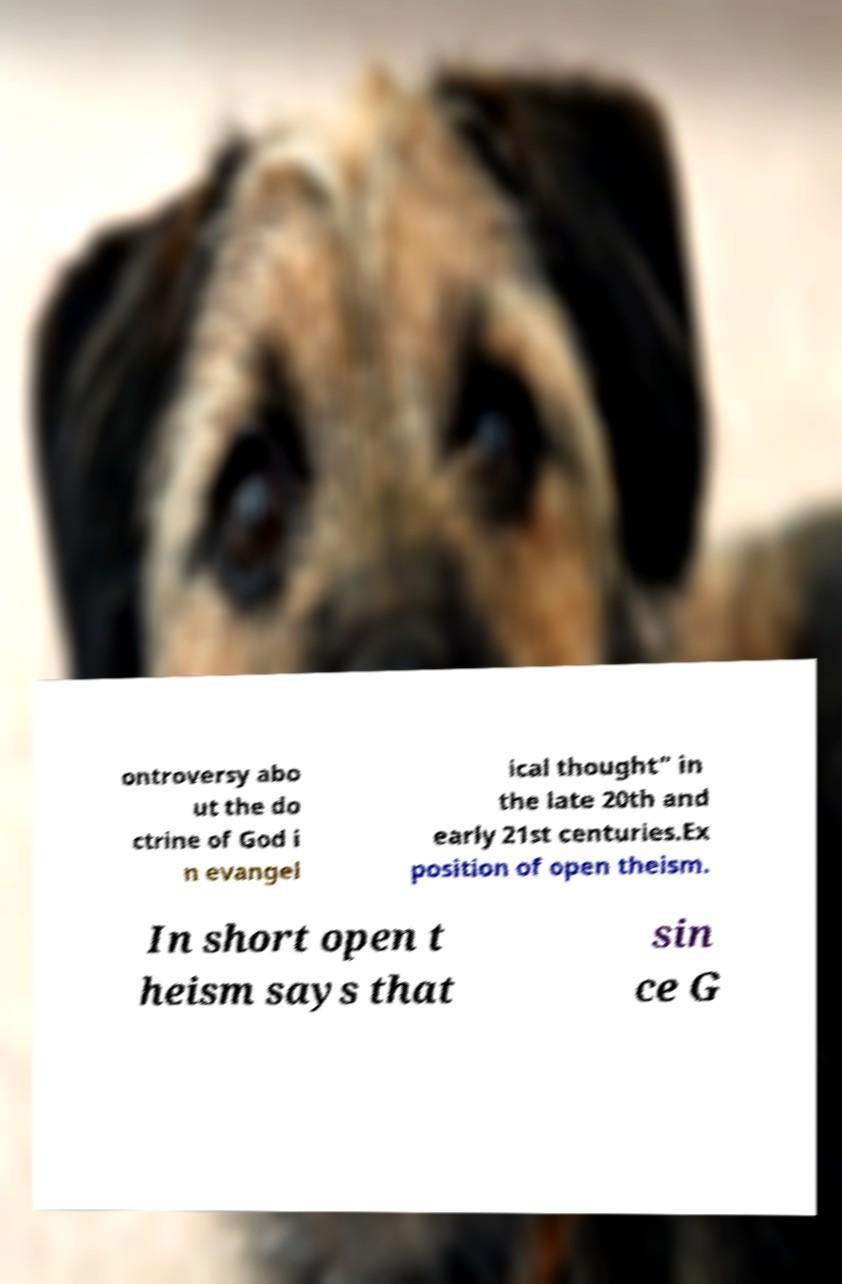Please read and relay the text visible in this image. What does it say? ontroversy abo ut the do ctrine of God i n evangel ical thought" in the late 20th and early 21st centuries.Ex position of open theism. In short open t heism says that sin ce G 